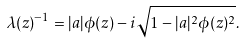<formula> <loc_0><loc_0><loc_500><loc_500>\lambda ( z ) ^ { - 1 } = | a | \phi ( z ) - i \sqrt { 1 - | a | ^ { 2 } \phi ( z ) ^ { 2 } } .</formula> 